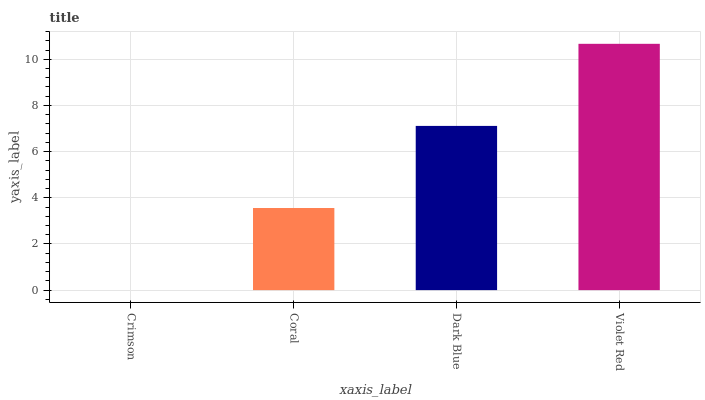Is Crimson the minimum?
Answer yes or no. Yes. Is Violet Red the maximum?
Answer yes or no. Yes. Is Coral the minimum?
Answer yes or no. No. Is Coral the maximum?
Answer yes or no. No. Is Coral greater than Crimson?
Answer yes or no. Yes. Is Crimson less than Coral?
Answer yes or no. Yes. Is Crimson greater than Coral?
Answer yes or no. No. Is Coral less than Crimson?
Answer yes or no. No. Is Dark Blue the high median?
Answer yes or no. Yes. Is Coral the low median?
Answer yes or no. Yes. Is Violet Red the high median?
Answer yes or no. No. Is Crimson the low median?
Answer yes or no. No. 